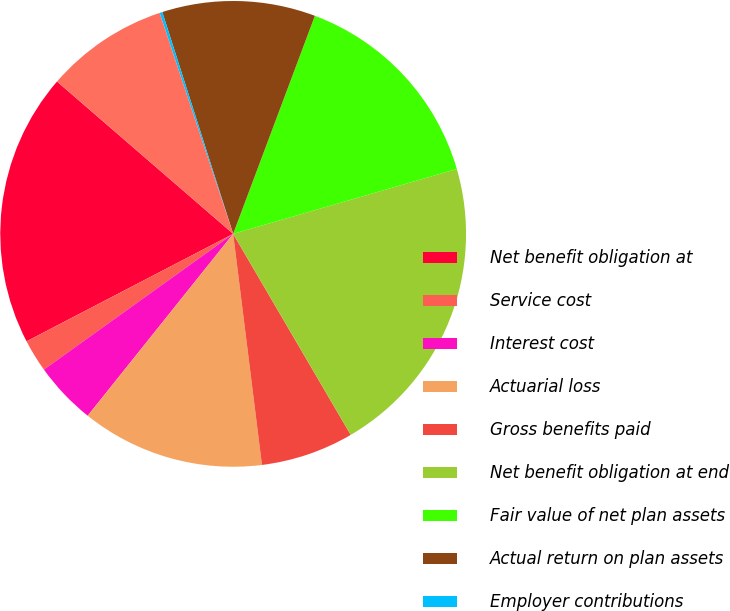<chart> <loc_0><loc_0><loc_500><loc_500><pie_chart><fcel>Net benefit obligation at<fcel>Service cost<fcel>Interest cost<fcel>Actuarial loss<fcel>Gross benefits paid<fcel>Net benefit obligation at end<fcel>Fair value of net plan assets<fcel>Actual return on plan assets<fcel>Employer contributions<fcel>Benefits paid (a)<nl><fcel>18.98%<fcel>2.27%<fcel>4.36%<fcel>12.71%<fcel>6.45%<fcel>21.07%<fcel>14.8%<fcel>10.63%<fcel>0.19%<fcel>8.54%<nl></chart> 